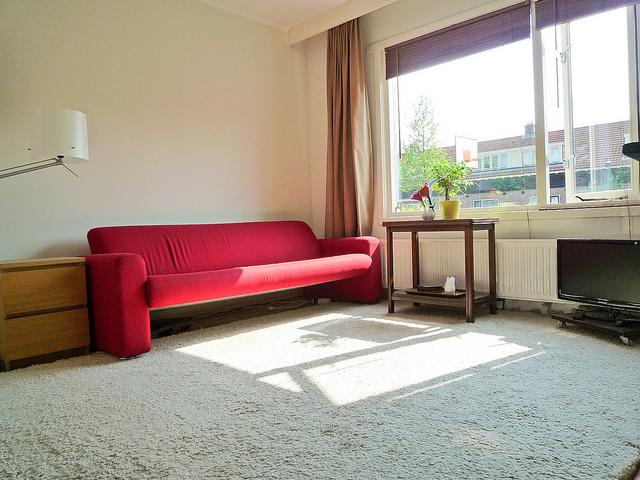Is the TV facing the couch?
Quick response, please. No. What color is the carpet?
Write a very short answer. White. What is the TV sitting on?
Quick response, please. Floor. 